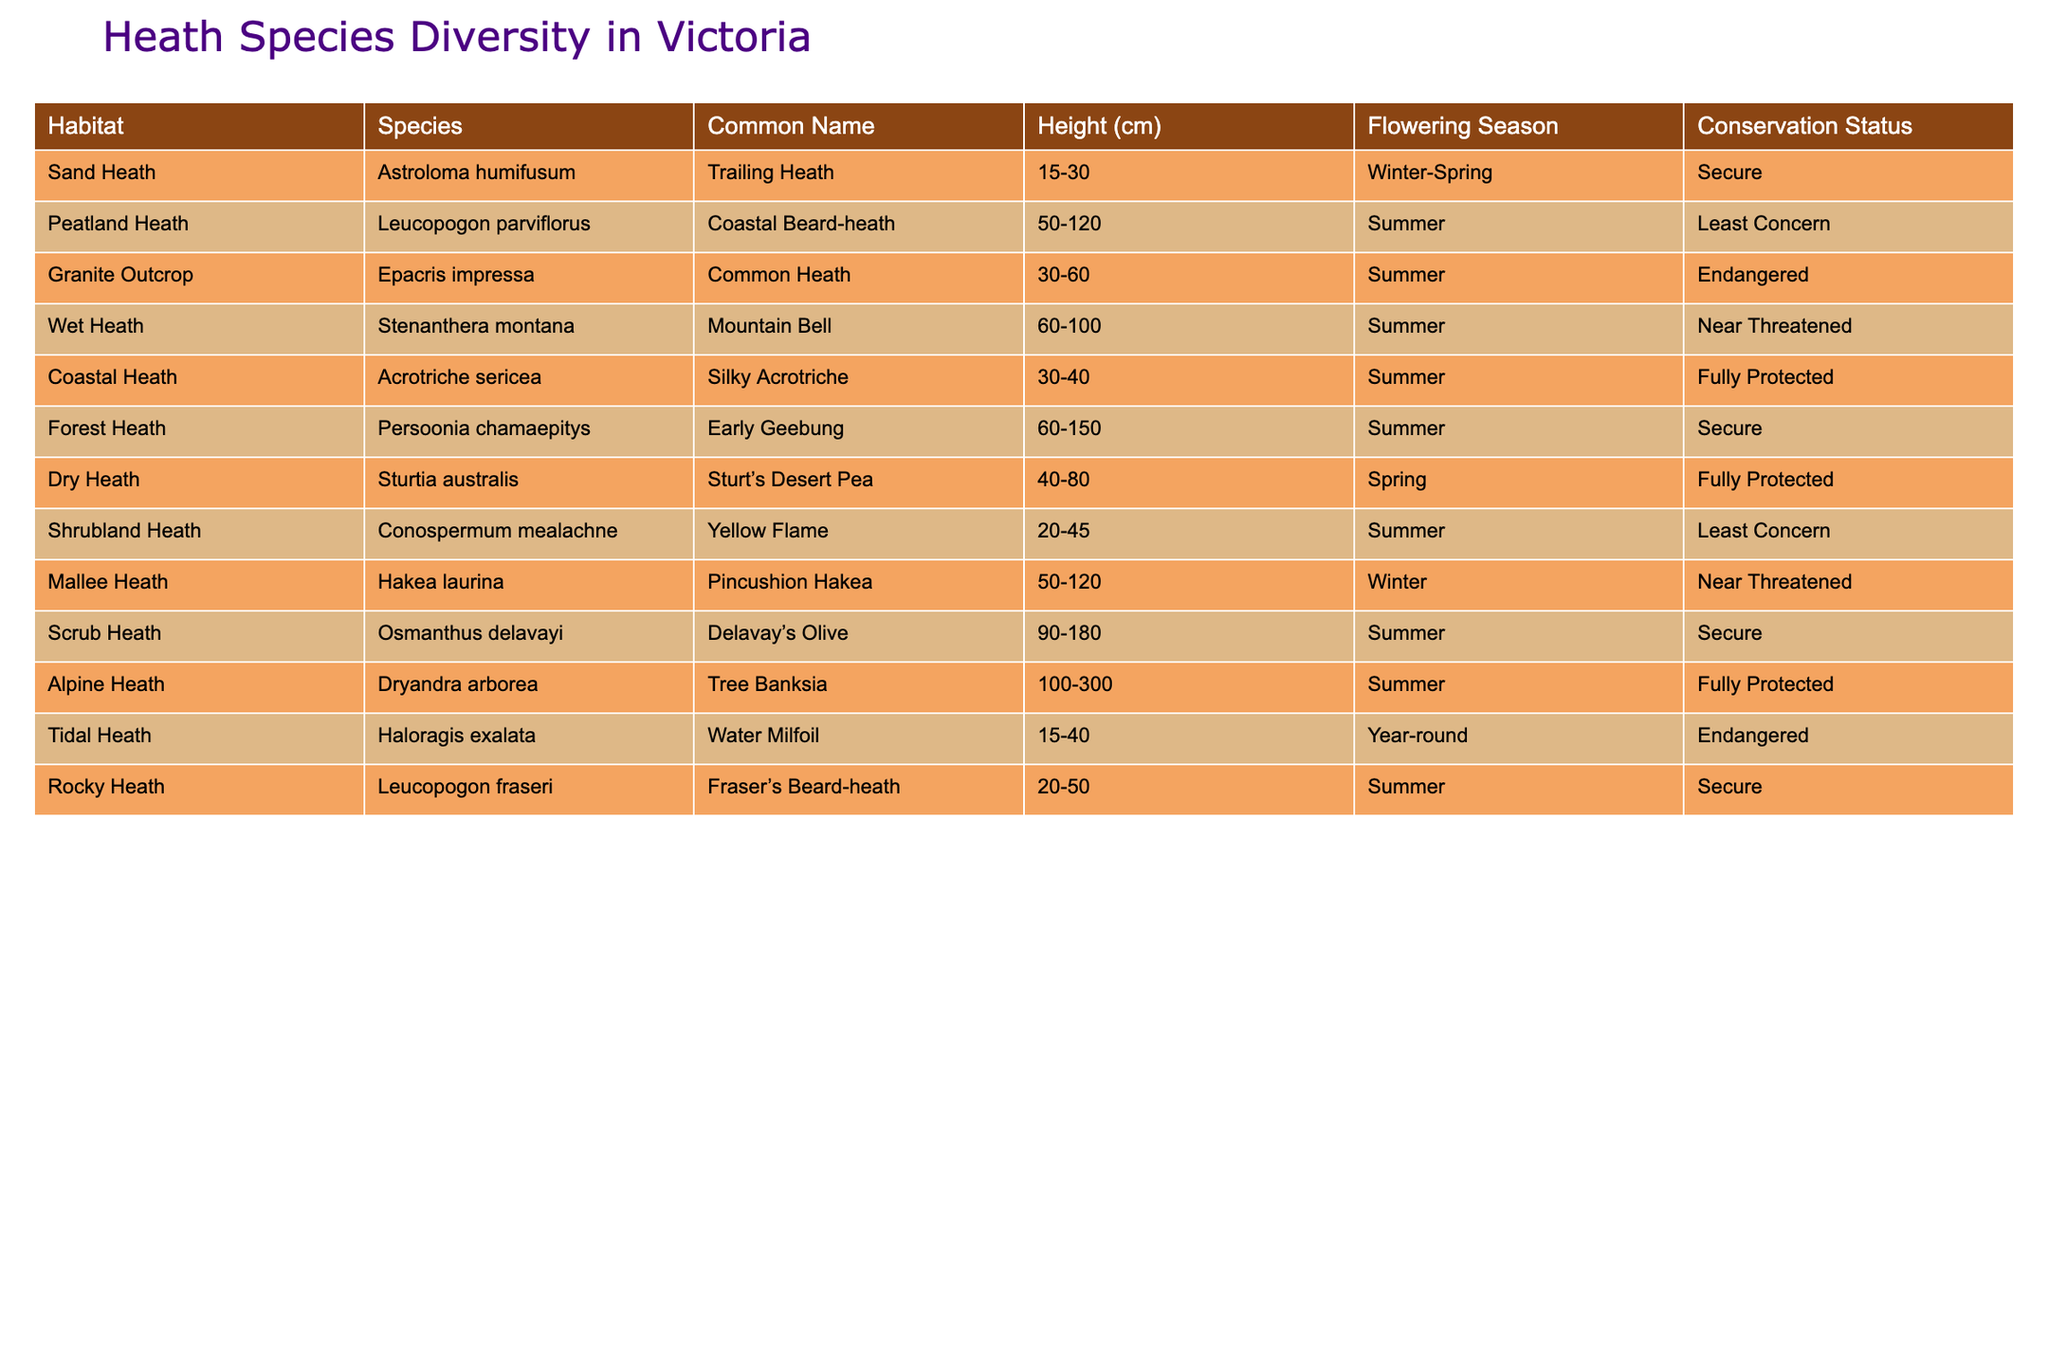What habitat is associated with the Coastal Beard-heath? The table lists the Coastal Beard-heath under the Peatland Heath habitat.
Answer: Peatland Heath What is the flowering season for Mountain Bell? Referring to the table, the Mountain Bell is noted to flower in Summer.
Answer: Summer Which species has the maximum height range? By reviewing the height ranges listed, the Tree Banksia has the maximum range of 100-300 cm.
Answer: Tree Banksia Are there any endangered species in the table? The table lists an endangered species, the Common Heath, and the Water Milfoil.
Answer: Yes How many species have a conservation status of Least Concern? The table shows two species, namely Coastal Beard-heath and Yellow Flame, labeled as Least Concern.
Answer: 2 What are the common names of the species in the Rocky Heath habitat? The table shows the Fraser's Beard-heath under the Rocky Heath habitat.
Answer: Fraser's Beard-heath Which habitat supports the tallest species based on the height range? The Tree Banksia in the Alpine Heath has the tallest height range (100-300 cm), indicating this habitat supports the tallest species.
Answer: Alpine Heath What is the difference in height range between the Trail Heath and the Mallee Heath? The height range of Trailing Heath is 15-30 cm, and for Pincushion Hakea, it's 50-120 cm; the difference is (120 - 30 = 90) cm.
Answer: 90 cm List all species that flower in Summer. The table lists Coastal Beard-heath, Common Heath, Mountain Bell, Silky Acrotriche, Early Geebung, Pincushion Hakea, Delavay’s Olive, Tree Banksia, and Fraser’s Beard-heath as flowering in Summer.
Answer: 9 species Which habitat has the highest species count and what is that species? The table suggests that Coastal Heath habitat has species counts of 1, shared with Dry Heath; however, Dry Heath also features one species. Therefore, both habitats have the highest species count of 1 each.
Answer: 1 species in both Coastal Heath and Dry Heath Are there any fully protected species in the Wet Heath habitat? The table does not list any species in the Wet Heath habitat as fully protected; the Mountain Bell is noted as Near Threatened.
Answer: No 